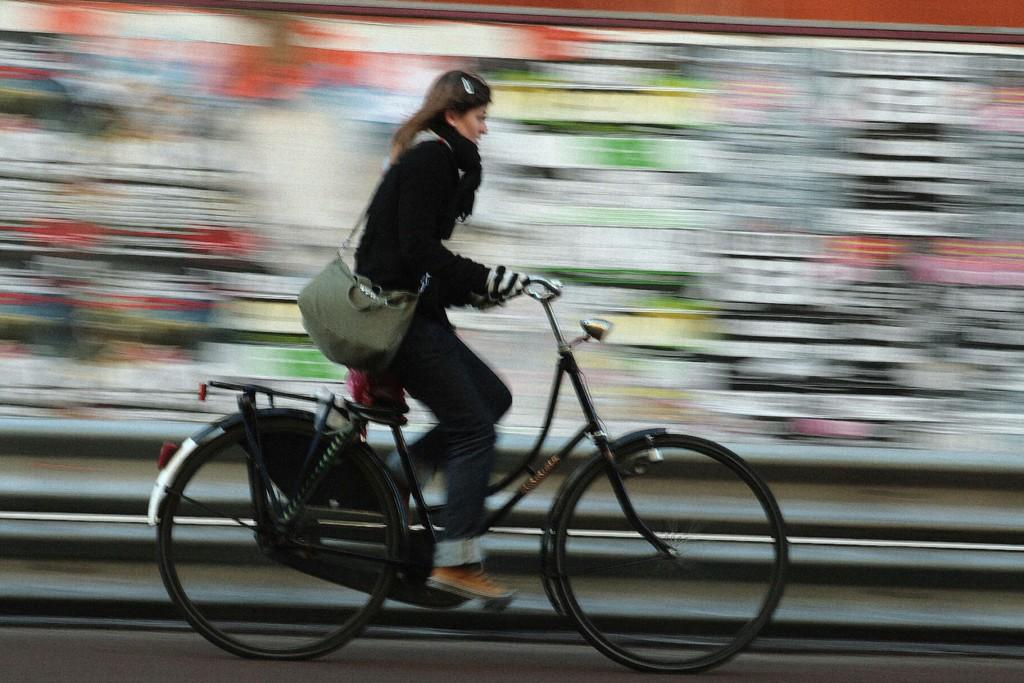Who is the main subject in the image? There is a girl in the image. Where is the girl positioned in the image? The girl is at the center of the image. What is the girl doing in the image? The girl is riding a bicycle. What else is the girl carrying in the image? The girl is carrying a handbag. What type of cub can be seen playing with the girl in the image? There is no cub present in the image; the girl is riding a bicycle and carrying a handbag. 